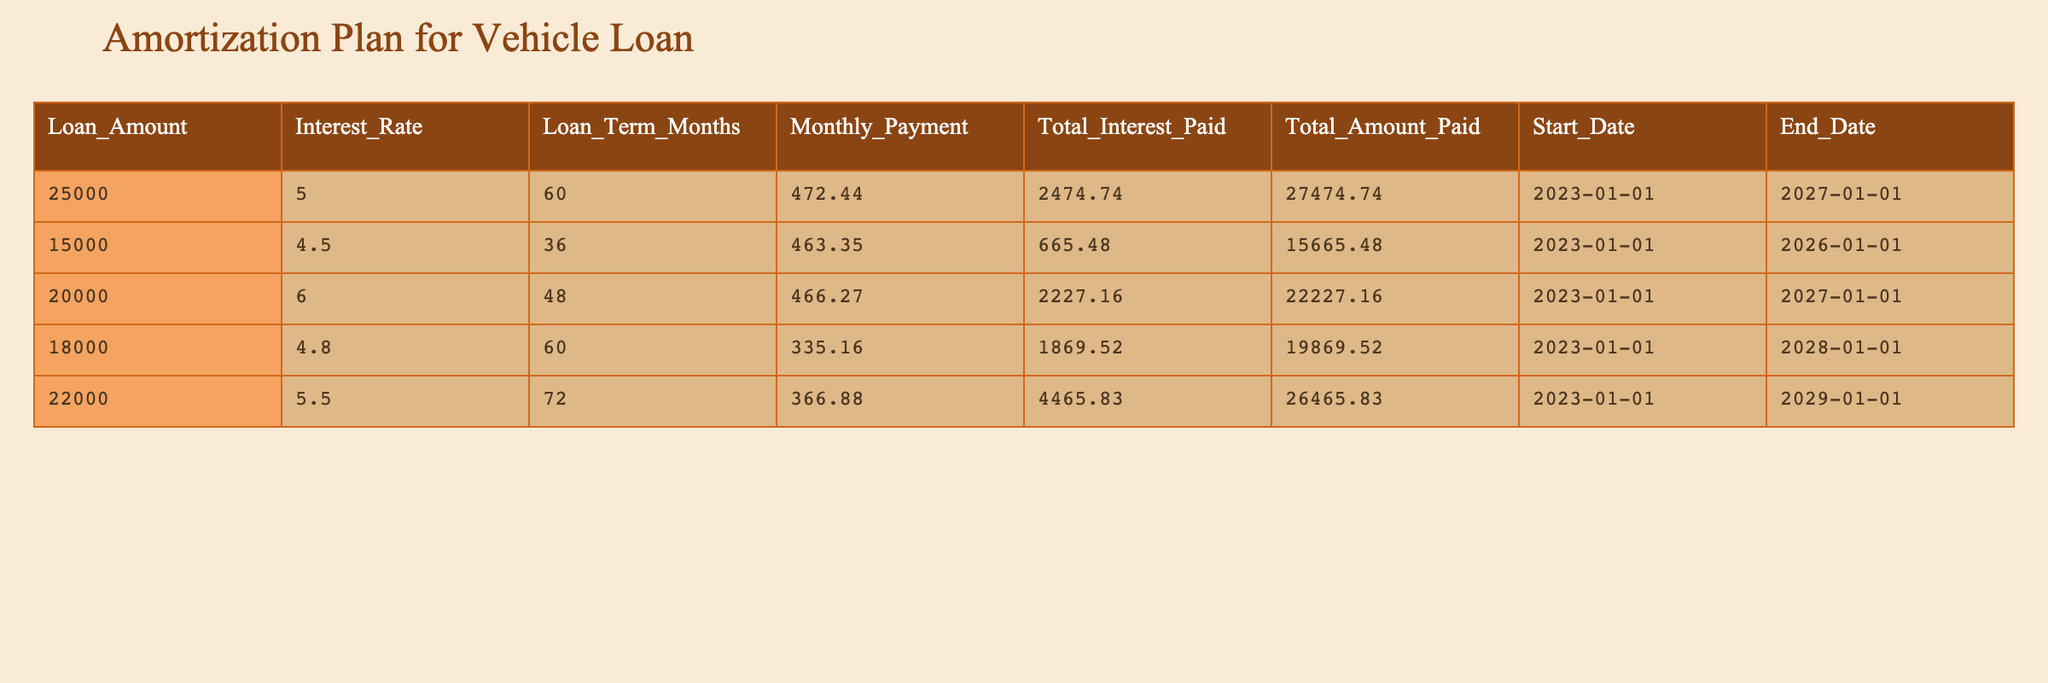What is the loan amount for the vehicle with the highest interest rate? The highest interest rate in the table is 6.0%, which corresponds to a loan amount of 20000.
Answer: 20000 What is the total interest paid for the loan amount of 15000? From the table, it shows that the total interest paid for the 15000 loan is 665.48.
Answer: 665.48 How much will be paid in total for the loan with an amount of 25000? Referring to the table, the total amount paid for the 25000 loan is 27474.74.
Answer: 27474.74 Which loan has the shortest term? To find the shortest term, look at the "Loan Term Months" column; the shortest term is 36 months for the loan amount of 15000.
Answer: 15000 If I wanted to calculate the average monthly payment of all loans, how would I do that? The monthly payments are 472.44, 463.35, 466.27, 335.16, and 366.88. The total is 472.44 + 463.35 + 466.27 + 335.16 + 366.88 = 2064.10. There are 5 loans, so the average is 2064.10 / 5 = 412.82.
Answer: 412.82 Is the loan amount of 22000 paid off before the end of 2029? The end date for the loan amount of 22000 is the end of 2029, so it is indeed paid off right before that year ends.
Answer: Yes How much total interest will be paid across all loans? By adding the total interest from each loan: 2474.74 + 665.48 + 2227.16 + 1869.52 + 4465.83 = 11502.73.
Answer: 11502.73 Does the loan of 18000 have a lower monthly payment than the loan of 25000? The monthly payment for the 18000 loan is 335.16, while for the 25000 loan it is 472.44, confirming 18000 has a lower payment.
Answer: Yes What is the difference in total amounts paid between the loans of 22000 and 20000? The total amount paid for 22000 is 26465.83 and for 20000 is 22227.16. Therefore, the difference is 26465.83 - 22227.16 = 4248.67.
Answer: 4248.67 